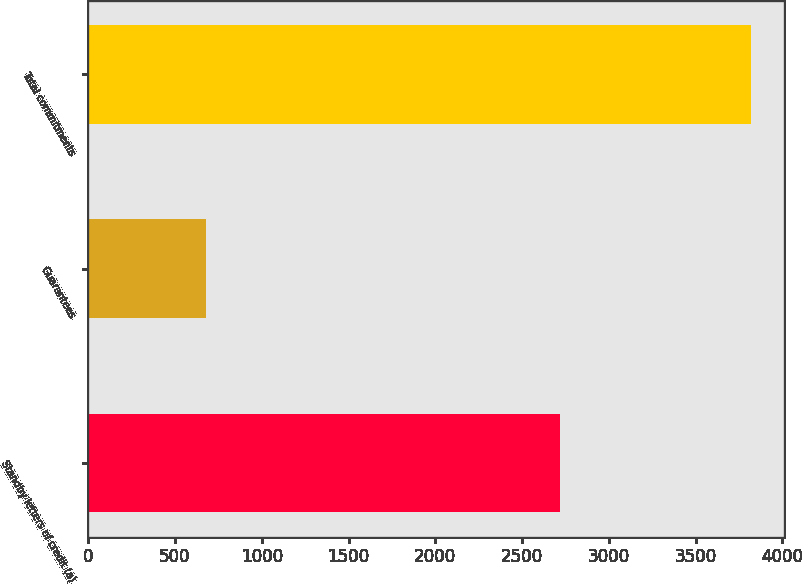Convert chart. <chart><loc_0><loc_0><loc_500><loc_500><bar_chart><fcel>Standby letters of credit (a)<fcel>Guarantees<fcel>Total commitments<nl><fcel>2718<fcel>678<fcel>3821<nl></chart> 